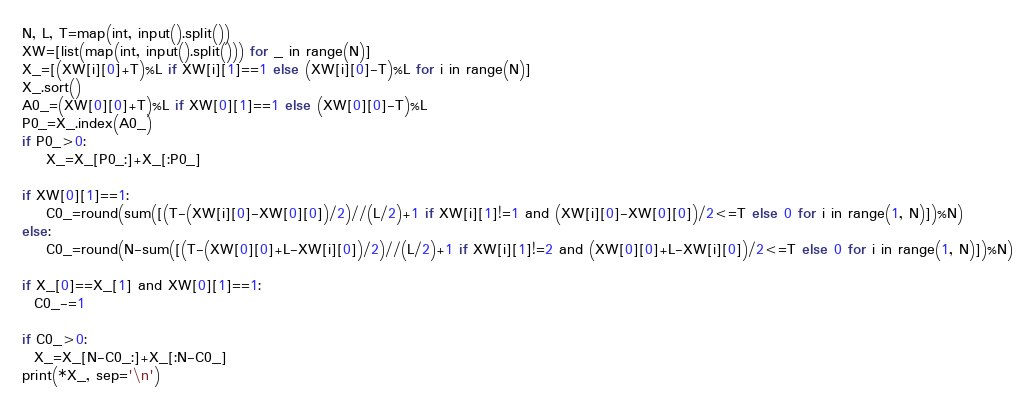<code> <loc_0><loc_0><loc_500><loc_500><_Python_>N, L, T=map(int, input().split())
XW=[list(map(int, input().split())) for _ in range(N)]
X_=[(XW[i][0]+T)%L if XW[i][1]==1 else (XW[i][0]-T)%L for i in range(N)]
X_.sort()
A0_=(XW[0][0]+T)%L if XW[0][1]==1 else (XW[0][0]-T)%L
P0_=X_.index(A0_)
if P0_>0:
    X_=X_[P0_:]+X_[:P0_]
    
if XW[0][1]==1:
    C0_=round(sum([(T-(XW[i][0]-XW[0][0])/2)//(L/2)+1 if XW[i][1]!=1 and (XW[i][0]-XW[0][0])/2<=T else 0 for i in range(1, N)])%N)
else:
    C0_=round(N-sum([(T-(XW[0][0]+L-XW[i][0])/2)//(L/2)+1 if XW[i][1]!=2 and (XW[0][0]+L-XW[i][0])/2<=T else 0 for i in range(1, N)])%N)
    
if X_[0]==X_[1] and XW[0][1]==1:
  C0_-=1
  
if C0_>0:
  X_=X_[N-C0_:]+X_[:N-C0_]
print(*X_, sep='\n')</code> 